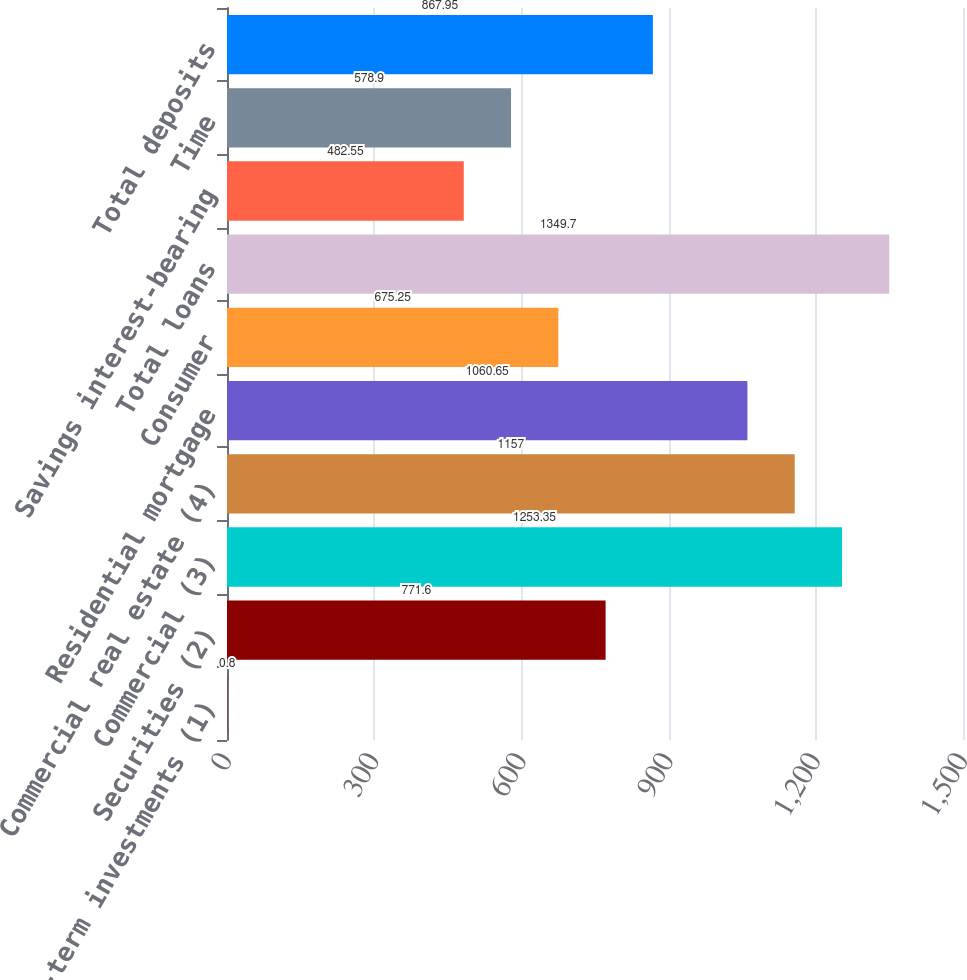Convert chart to OTSL. <chart><loc_0><loc_0><loc_500><loc_500><bar_chart><fcel>Short-term investments (1)<fcel>Securities (2)<fcel>Commercial (3)<fcel>Commercial real estate (4)<fcel>Residential mortgage<fcel>Consumer<fcel>Total loans<fcel>Savings interest-bearing<fcel>Time<fcel>Total deposits<nl><fcel>0.8<fcel>771.6<fcel>1253.35<fcel>1157<fcel>1060.65<fcel>675.25<fcel>1349.7<fcel>482.55<fcel>578.9<fcel>867.95<nl></chart> 